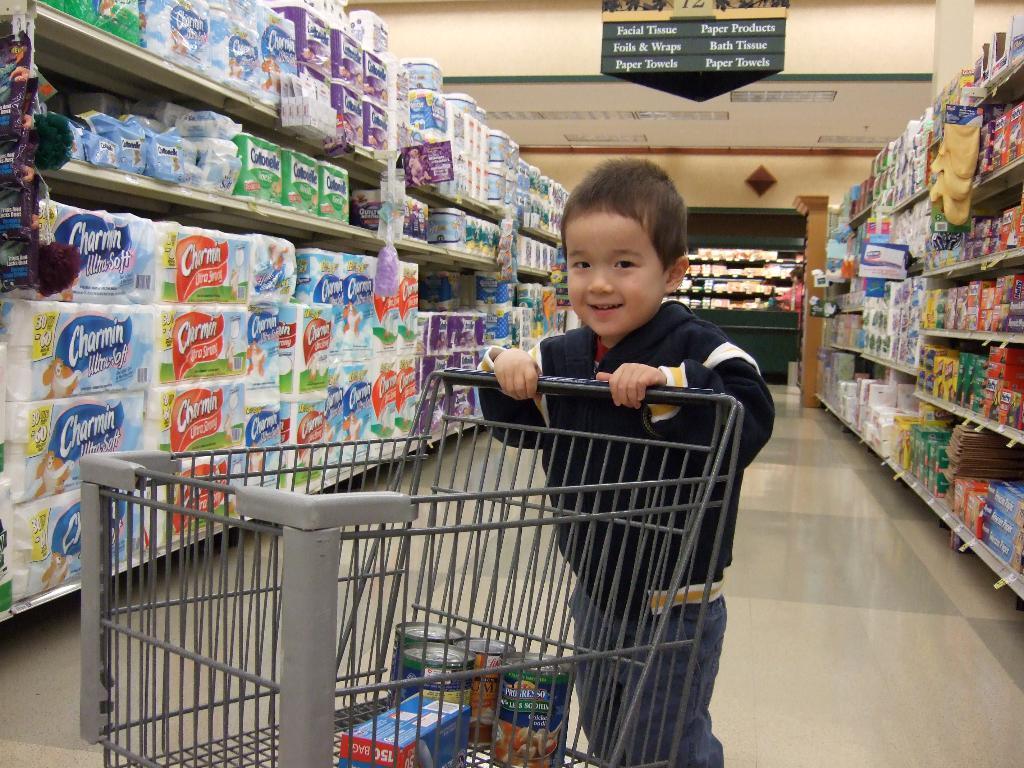What is found in this aisle?
Give a very brief answer. Paper products. What brand of toilet paper is that at the very left?
Ensure brevity in your answer.  Charmin. 